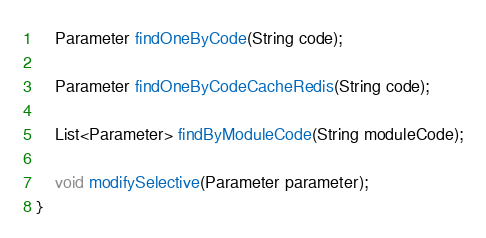<code> <loc_0><loc_0><loc_500><loc_500><_Java_>
	Parameter findOneByCode(String code);
	
	Parameter findOneByCodeCacheRedis(String code);
	
	List<Parameter> findByModuleCode(String moduleCode);
	
	void modifySelective(Parameter parameter);
}
</code> 